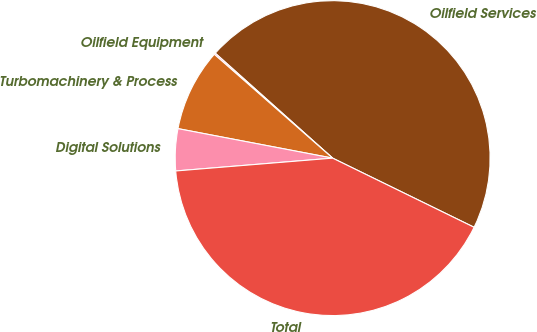Convert chart. <chart><loc_0><loc_0><loc_500><loc_500><pie_chart><fcel>Oilfield Services<fcel>Oilfield Equipment<fcel>Turbomachinery & Process<fcel>Digital Solutions<fcel>Total<nl><fcel>45.62%<fcel>0.15%<fcel>8.46%<fcel>4.3%<fcel>41.46%<nl></chart> 